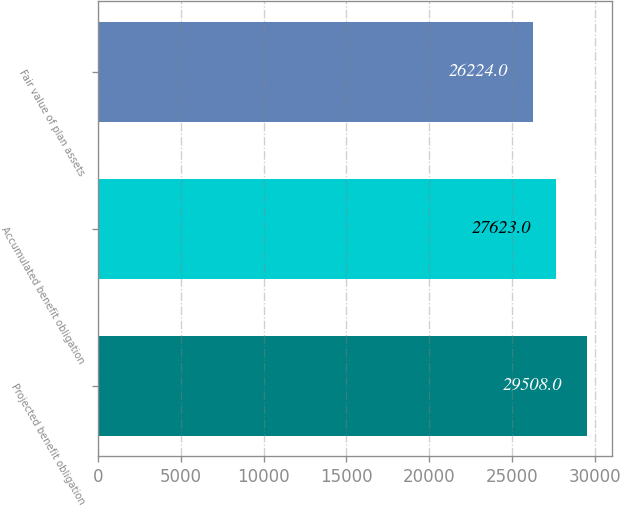Convert chart. <chart><loc_0><loc_0><loc_500><loc_500><bar_chart><fcel>Projected benefit obligation<fcel>Accumulated benefit obligation<fcel>Fair value of plan assets<nl><fcel>29508<fcel>27623<fcel>26224<nl></chart> 